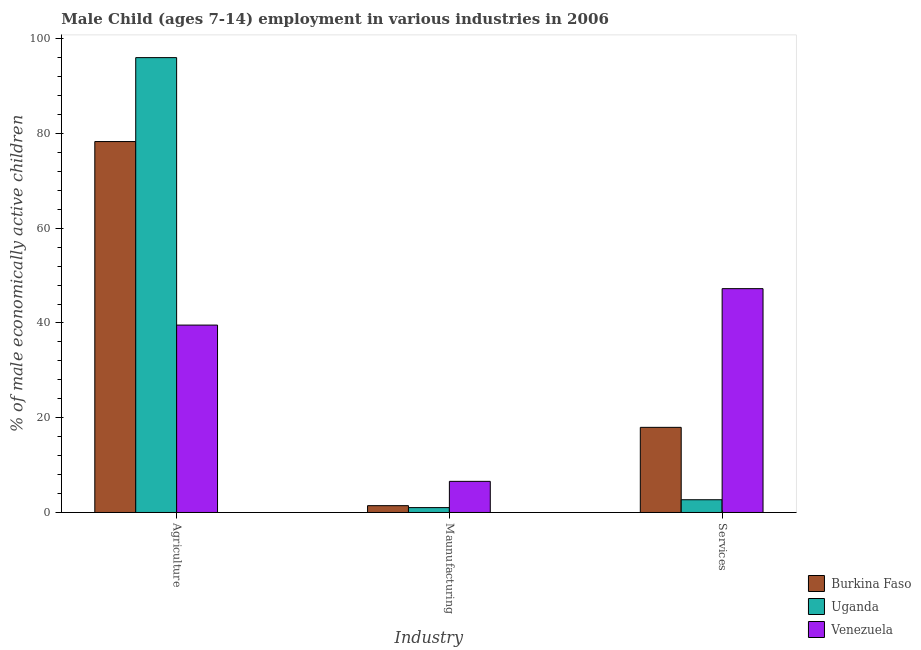How many groups of bars are there?
Make the answer very short. 3. What is the label of the 2nd group of bars from the left?
Your answer should be compact. Maunufacturing. What is the percentage of economically active children in agriculture in Uganda?
Provide a succinct answer. 96.02. Across all countries, what is the maximum percentage of economically active children in services?
Offer a very short reply. 47.25. Across all countries, what is the minimum percentage of economically active children in agriculture?
Your answer should be compact. 39.56. In which country was the percentage of economically active children in services maximum?
Make the answer very short. Venezuela. In which country was the percentage of economically active children in agriculture minimum?
Keep it short and to the point. Venezuela. What is the total percentage of economically active children in agriculture in the graph?
Provide a short and direct response. 213.88. What is the difference between the percentage of economically active children in services in Burkina Faso and that in Uganda?
Your answer should be very brief. 15.28. What is the difference between the percentage of economically active children in manufacturing in Burkina Faso and the percentage of economically active children in agriculture in Uganda?
Your answer should be compact. -94.58. What is the average percentage of economically active children in services per country?
Keep it short and to the point. 22.64. What is the difference between the percentage of economically active children in services and percentage of economically active children in manufacturing in Venezuela?
Your answer should be very brief. 40.68. What is the ratio of the percentage of economically active children in agriculture in Venezuela to that in Uganda?
Your answer should be compact. 0.41. Is the difference between the percentage of economically active children in services in Uganda and Burkina Faso greater than the difference between the percentage of economically active children in manufacturing in Uganda and Burkina Faso?
Keep it short and to the point. No. What is the difference between the highest and the second highest percentage of economically active children in services?
Offer a very short reply. 29.28. What is the difference between the highest and the lowest percentage of economically active children in services?
Provide a succinct answer. 44.56. In how many countries, is the percentage of economically active children in manufacturing greater than the average percentage of economically active children in manufacturing taken over all countries?
Make the answer very short. 1. What does the 1st bar from the left in Maunufacturing represents?
Your answer should be very brief. Burkina Faso. What does the 2nd bar from the right in Maunufacturing represents?
Your answer should be compact. Uganda. Are the values on the major ticks of Y-axis written in scientific E-notation?
Ensure brevity in your answer.  No. Does the graph contain any zero values?
Provide a short and direct response. No. Where does the legend appear in the graph?
Your answer should be compact. Bottom right. How many legend labels are there?
Keep it short and to the point. 3. What is the title of the graph?
Make the answer very short. Male Child (ages 7-14) employment in various industries in 2006. What is the label or title of the X-axis?
Provide a succinct answer. Industry. What is the label or title of the Y-axis?
Offer a very short reply. % of male economically active children. What is the % of male economically active children of Burkina Faso in Agriculture?
Your answer should be very brief. 78.3. What is the % of male economically active children in Uganda in Agriculture?
Give a very brief answer. 96.02. What is the % of male economically active children of Venezuela in Agriculture?
Your answer should be very brief. 39.56. What is the % of male economically active children in Burkina Faso in Maunufacturing?
Keep it short and to the point. 1.44. What is the % of male economically active children of Venezuela in Maunufacturing?
Ensure brevity in your answer.  6.57. What is the % of male economically active children of Burkina Faso in Services?
Keep it short and to the point. 17.97. What is the % of male economically active children in Uganda in Services?
Your answer should be compact. 2.69. What is the % of male economically active children in Venezuela in Services?
Give a very brief answer. 47.25. Across all Industry, what is the maximum % of male economically active children in Burkina Faso?
Keep it short and to the point. 78.3. Across all Industry, what is the maximum % of male economically active children of Uganda?
Keep it short and to the point. 96.02. Across all Industry, what is the maximum % of male economically active children in Venezuela?
Your answer should be very brief. 47.25. Across all Industry, what is the minimum % of male economically active children of Burkina Faso?
Provide a short and direct response. 1.44. Across all Industry, what is the minimum % of male economically active children of Uganda?
Ensure brevity in your answer.  1.03. Across all Industry, what is the minimum % of male economically active children of Venezuela?
Give a very brief answer. 6.57. What is the total % of male economically active children of Burkina Faso in the graph?
Provide a short and direct response. 97.71. What is the total % of male economically active children in Uganda in the graph?
Ensure brevity in your answer.  99.74. What is the total % of male economically active children in Venezuela in the graph?
Make the answer very short. 93.38. What is the difference between the % of male economically active children of Burkina Faso in Agriculture and that in Maunufacturing?
Provide a succinct answer. 76.86. What is the difference between the % of male economically active children in Uganda in Agriculture and that in Maunufacturing?
Your response must be concise. 94.99. What is the difference between the % of male economically active children of Venezuela in Agriculture and that in Maunufacturing?
Make the answer very short. 32.99. What is the difference between the % of male economically active children of Burkina Faso in Agriculture and that in Services?
Offer a very short reply. 60.33. What is the difference between the % of male economically active children in Uganda in Agriculture and that in Services?
Offer a terse response. 93.33. What is the difference between the % of male economically active children of Venezuela in Agriculture and that in Services?
Your response must be concise. -7.69. What is the difference between the % of male economically active children of Burkina Faso in Maunufacturing and that in Services?
Offer a terse response. -16.53. What is the difference between the % of male economically active children in Uganda in Maunufacturing and that in Services?
Provide a succinct answer. -1.66. What is the difference between the % of male economically active children of Venezuela in Maunufacturing and that in Services?
Your response must be concise. -40.68. What is the difference between the % of male economically active children of Burkina Faso in Agriculture and the % of male economically active children of Uganda in Maunufacturing?
Your answer should be compact. 77.27. What is the difference between the % of male economically active children of Burkina Faso in Agriculture and the % of male economically active children of Venezuela in Maunufacturing?
Give a very brief answer. 71.73. What is the difference between the % of male economically active children of Uganda in Agriculture and the % of male economically active children of Venezuela in Maunufacturing?
Your answer should be compact. 89.45. What is the difference between the % of male economically active children of Burkina Faso in Agriculture and the % of male economically active children of Uganda in Services?
Your answer should be compact. 75.61. What is the difference between the % of male economically active children in Burkina Faso in Agriculture and the % of male economically active children in Venezuela in Services?
Offer a terse response. 31.05. What is the difference between the % of male economically active children of Uganda in Agriculture and the % of male economically active children of Venezuela in Services?
Give a very brief answer. 48.77. What is the difference between the % of male economically active children in Burkina Faso in Maunufacturing and the % of male economically active children in Uganda in Services?
Keep it short and to the point. -1.25. What is the difference between the % of male economically active children of Burkina Faso in Maunufacturing and the % of male economically active children of Venezuela in Services?
Give a very brief answer. -45.81. What is the difference between the % of male economically active children in Uganda in Maunufacturing and the % of male economically active children in Venezuela in Services?
Your response must be concise. -46.22. What is the average % of male economically active children of Burkina Faso per Industry?
Offer a very short reply. 32.57. What is the average % of male economically active children in Uganda per Industry?
Your answer should be compact. 33.25. What is the average % of male economically active children in Venezuela per Industry?
Your answer should be compact. 31.13. What is the difference between the % of male economically active children in Burkina Faso and % of male economically active children in Uganda in Agriculture?
Provide a short and direct response. -17.72. What is the difference between the % of male economically active children in Burkina Faso and % of male economically active children in Venezuela in Agriculture?
Provide a short and direct response. 38.74. What is the difference between the % of male economically active children in Uganda and % of male economically active children in Venezuela in Agriculture?
Your response must be concise. 56.46. What is the difference between the % of male economically active children in Burkina Faso and % of male economically active children in Uganda in Maunufacturing?
Your answer should be compact. 0.41. What is the difference between the % of male economically active children of Burkina Faso and % of male economically active children of Venezuela in Maunufacturing?
Ensure brevity in your answer.  -5.13. What is the difference between the % of male economically active children of Uganda and % of male economically active children of Venezuela in Maunufacturing?
Give a very brief answer. -5.54. What is the difference between the % of male economically active children in Burkina Faso and % of male economically active children in Uganda in Services?
Your answer should be compact. 15.28. What is the difference between the % of male economically active children of Burkina Faso and % of male economically active children of Venezuela in Services?
Offer a very short reply. -29.28. What is the difference between the % of male economically active children of Uganda and % of male economically active children of Venezuela in Services?
Offer a terse response. -44.56. What is the ratio of the % of male economically active children of Burkina Faso in Agriculture to that in Maunufacturing?
Offer a very short reply. 54.38. What is the ratio of the % of male economically active children in Uganda in Agriculture to that in Maunufacturing?
Offer a very short reply. 93.22. What is the ratio of the % of male economically active children in Venezuela in Agriculture to that in Maunufacturing?
Offer a terse response. 6.02. What is the ratio of the % of male economically active children of Burkina Faso in Agriculture to that in Services?
Give a very brief answer. 4.36. What is the ratio of the % of male economically active children in Uganda in Agriculture to that in Services?
Offer a terse response. 35.7. What is the ratio of the % of male economically active children of Venezuela in Agriculture to that in Services?
Your answer should be very brief. 0.84. What is the ratio of the % of male economically active children of Burkina Faso in Maunufacturing to that in Services?
Keep it short and to the point. 0.08. What is the ratio of the % of male economically active children of Uganda in Maunufacturing to that in Services?
Your answer should be compact. 0.38. What is the ratio of the % of male economically active children of Venezuela in Maunufacturing to that in Services?
Give a very brief answer. 0.14. What is the difference between the highest and the second highest % of male economically active children in Burkina Faso?
Give a very brief answer. 60.33. What is the difference between the highest and the second highest % of male economically active children in Uganda?
Your answer should be very brief. 93.33. What is the difference between the highest and the second highest % of male economically active children in Venezuela?
Your answer should be very brief. 7.69. What is the difference between the highest and the lowest % of male economically active children of Burkina Faso?
Provide a succinct answer. 76.86. What is the difference between the highest and the lowest % of male economically active children in Uganda?
Make the answer very short. 94.99. What is the difference between the highest and the lowest % of male economically active children of Venezuela?
Provide a succinct answer. 40.68. 